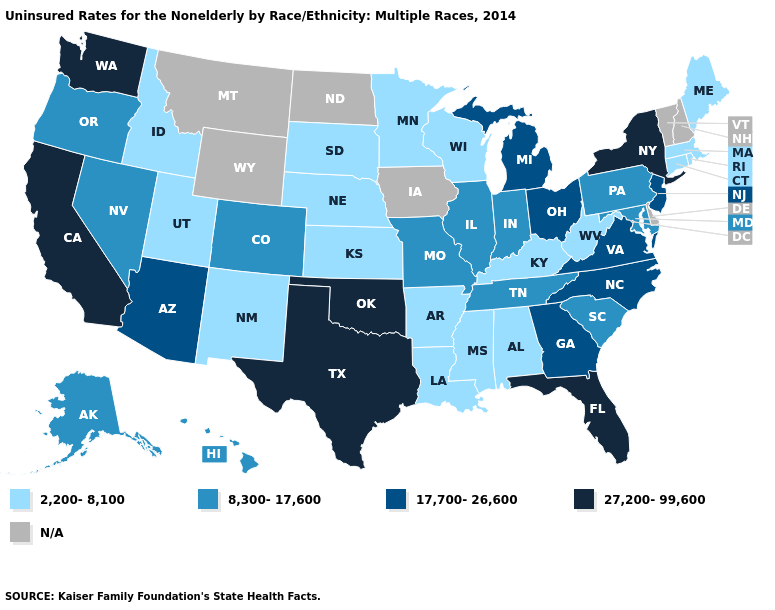Does Illinois have the highest value in the USA?
Be succinct. No. Which states have the highest value in the USA?
Be succinct. California, Florida, New York, Oklahoma, Texas, Washington. What is the highest value in the USA?
Give a very brief answer. 27,200-99,600. What is the highest value in the MidWest ?
Concise answer only. 17,700-26,600. Name the states that have a value in the range 17,700-26,600?
Quick response, please. Arizona, Georgia, Michigan, New Jersey, North Carolina, Ohio, Virginia. Which states hav the highest value in the South?
Write a very short answer. Florida, Oklahoma, Texas. Which states hav the highest value in the MidWest?
Quick response, please. Michigan, Ohio. Which states have the lowest value in the USA?
Short answer required. Alabama, Arkansas, Connecticut, Idaho, Kansas, Kentucky, Louisiana, Maine, Massachusetts, Minnesota, Mississippi, Nebraska, New Mexico, Rhode Island, South Dakota, Utah, West Virginia, Wisconsin. Is the legend a continuous bar?
Concise answer only. No. Does Connecticut have the highest value in the Northeast?
Be succinct. No. What is the value of Texas?
Short answer required. 27,200-99,600. What is the value of Michigan?
Keep it brief. 17,700-26,600. Does the map have missing data?
Give a very brief answer. Yes. 